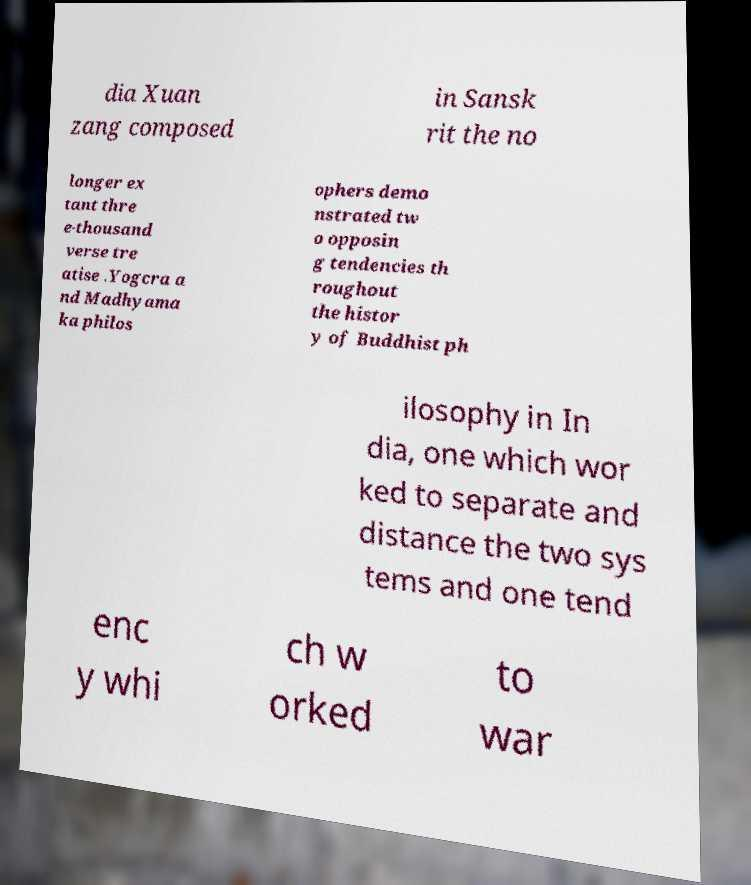For documentation purposes, I need the text within this image transcribed. Could you provide that? dia Xuan zang composed in Sansk rit the no longer ex tant thre e-thousand verse tre atise .Yogcra a nd Madhyama ka philos ophers demo nstrated tw o opposin g tendencies th roughout the histor y of Buddhist ph ilosophy in In dia, one which wor ked to separate and distance the two sys tems and one tend enc y whi ch w orked to war 